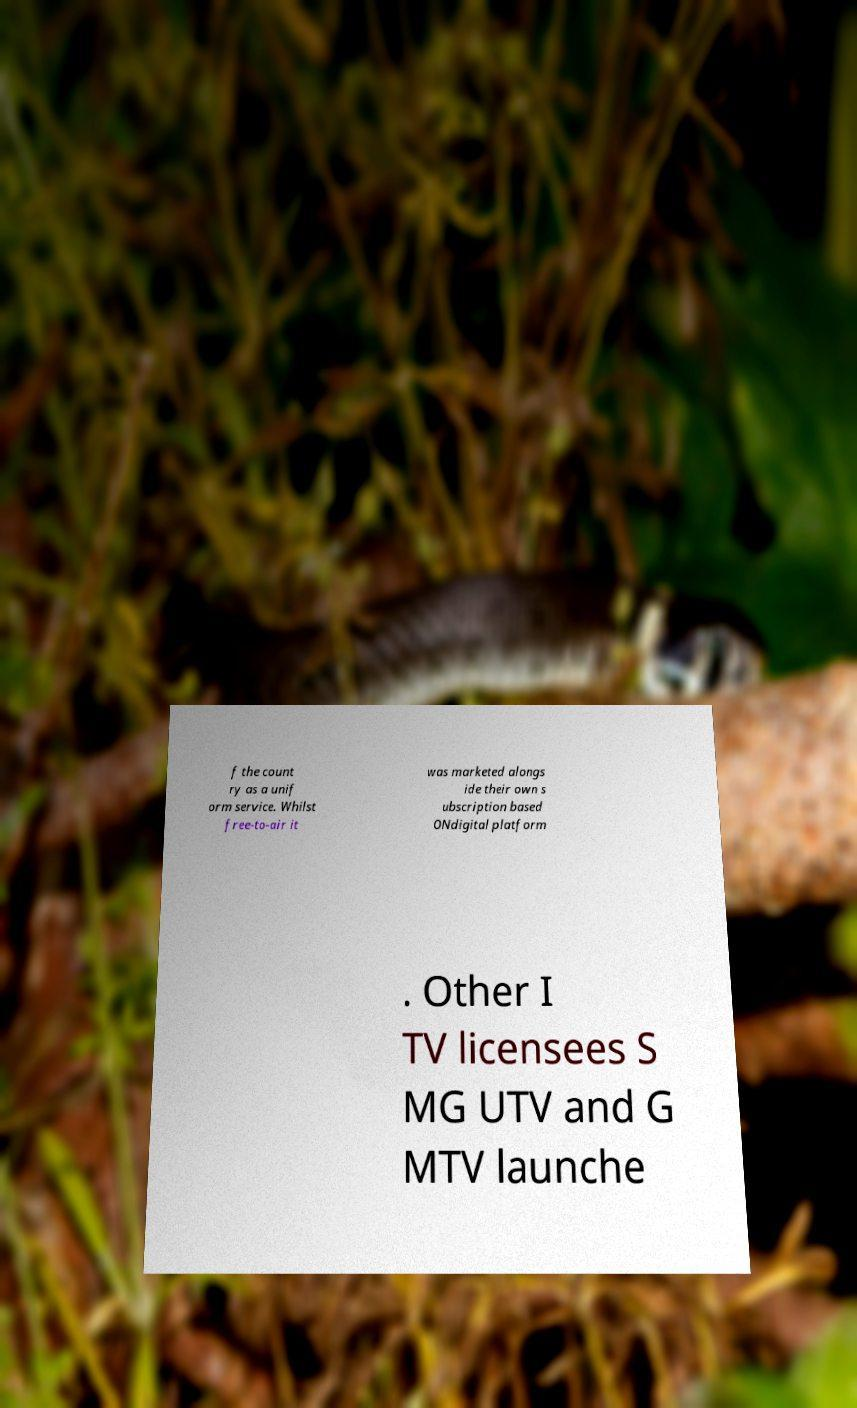Please identify and transcribe the text found in this image. f the count ry as a unif orm service. Whilst free-to-air it was marketed alongs ide their own s ubscription based ONdigital platform . Other I TV licensees S MG UTV and G MTV launche 